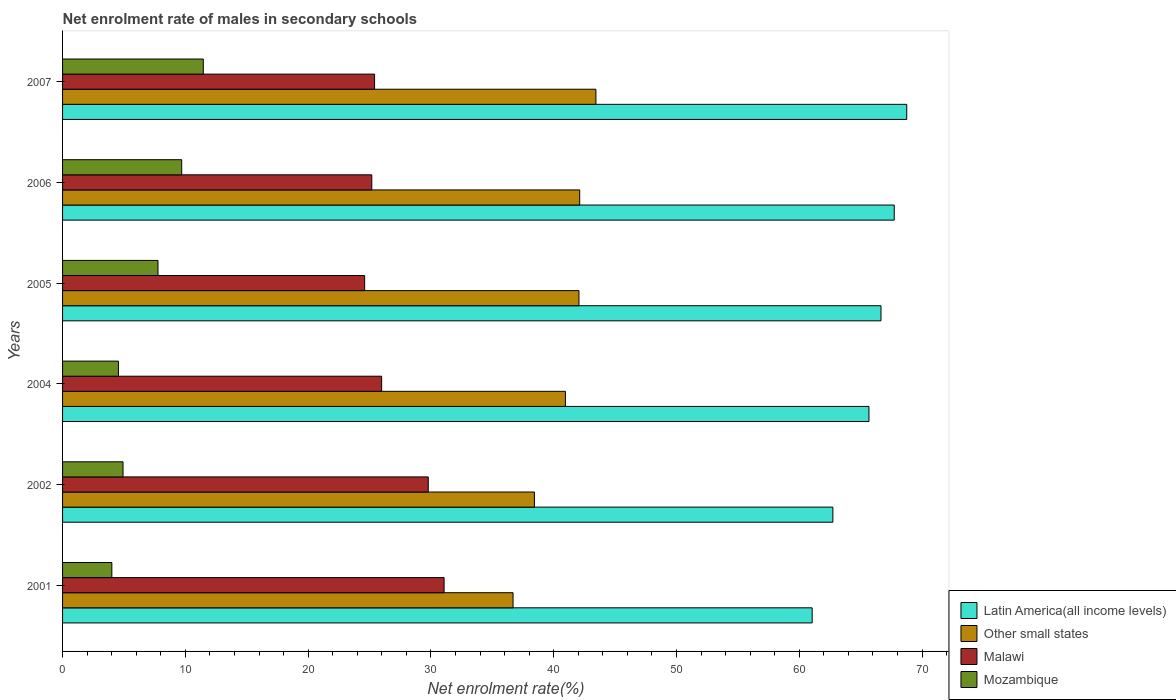How many different coloured bars are there?
Offer a very short reply. 4. Are the number of bars on each tick of the Y-axis equal?
Give a very brief answer. Yes. How many bars are there on the 1st tick from the top?
Keep it short and to the point. 4. How many bars are there on the 2nd tick from the bottom?
Provide a succinct answer. 4. What is the label of the 6th group of bars from the top?
Provide a succinct answer. 2001. What is the net enrolment rate of males in secondary schools in Malawi in 2007?
Your response must be concise. 25.41. Across all years, what is the maximum net enrolment rate of males in secondary schools in Malawi?
Offer a very short reply. 31.07. Across all years, what is the minimum net enrolment rate of males in secondary schools in Latin America(all income levels)?
Ensure brevity in your answer.  61.05. In which year was the net enrolment rate of males in secondary schools in Other small states minimum?
Provide a short and direct response. 2001. What is the total net enrolment rate of males in secondary schools in Latin America(all income levels) in the graph?
Make the answer very short. 392.62. What is the difference between the net enrolment rate of males in secondary schools in Other small states in 2001 and that in 2006?
Offer a terse response. -5.43. What is the difference between the net enrolment rate of males in secondary schools in Mozambique in 2007 and the net enrolment rate of males in secondary schools in Other small states in 2001?
Your answer should be very brief. -25.23. What is the average net enrolment rate of males in secondary schools in Malawi per year?
Offer a terse response. 27.01. In the year 2002, what is the difference between the net enrolment rate of males in secondary schools in Mozambique and net enrolment rate of males in secondary schools in Malawi?
Your answer should be compact. -24.86. In how many years, is the net enrolment rate of males in secondary schools in Malawi greater than 58 %?
Offer a very short reply. 0. What is the ratio of the net enrolment rate of males in secondary schools in Other small states in 2002 to that in 2005?
Your response must be concise. 0.91. Is the net enrolment rate of males in secondary schools in Latin America(all income levels) in 2002 less than that in 2007?
Your answer should be compact. Yes. What is the difference between the highest and the second highest net enrolment rate of males in secondary schools in Malawi?
Your response must be concise. 1.29. What is the difference between the highest and the lowest net enrolment rate of males in secondary schools in Malawi?
Your answer should be compact. 6.47. In how many years, is the net enrolment rate of males in secondary schools in Malawi greater than the average net enrolment rate of males in secondary schools in Malawi taken over all years?
Your answer should be very brief. 2. What does the 2nd bar from the top in 2001 represents?
Provide a succinct answer. Malawi. What does the 3rd bar from the bottom in 2004 represents?
Make the answer very short. Malawi. Is it the case that in every year, the sum of the net enrolment rate of males in secondary schools in Other small states and net enrolment rate of males in secondary schools in Malawi is greater than the net enrolment rate of males in secondary schools in Latin America(all income levels)?
Give a very brief answer. No. How many bars are there?
Keep it short and to the point. 24. Are the values on the major ticks of X-axis written in scientific E-notation?
Make the answer very short. No. Where does the legend appear in the graph?
Your response must be concise. Bottom right. What is the title of the graph?
Keep it short and to the point. Net enrolment rate of males in secondary schools. Does "Fragile and conflict affected situations" appear as one of the legend labels in the graph?
Provide a succinct answer. No. What is the label or title of the X-axis?
Your answer should be compact. Net enrolment rate(%). What is the Net enrolment rate(%) in Latin America(all income levels) in 2001?
Your response must be concise. 61.05. What is the Net enrolment rate(%) in Other small states in 2001?
Your response must be concise. 36.69. What is the Net enrolment rate(%) of Malawi in 2001?
Offer a terse response. 31.07. What is the Net enrolment rate(%) of Mozambique in 2001?
Make the answer very short. 4.01. What is the Net enrolment rate(%) in Latin America(all income levels) in 2002?
Ensure brevity in your answer.  62.74. What is the Net enrolment rate(%) of Other small states in 2002?
Keep it short and to the point. 38.43. What is the Net enrolment rate(%) in Malawi in 2002?
Offer a very short reply. 29.79. What is the Net enrolment rate(%) in Mozambique in 2002?
Offer a very short reply. 4.92. What is the Net enrolment rate(%) in Latin America(all income levels) in 2004?
Your answer should be very brief. 65.68. What is the Net enrolment rate(%) in Other small states in 2004?
Make the answer very short. 40.96. What is the Net enrolment rate(%) of Malawi in 2004?
Offer a terse response. 25.99. What is the Net enrolment rate(%) of Mozambique in 2004?
Offer a terse response. 4.55. What is the Net enrolment rate(%) in Latin America(all income levels) in 2005?
Your response must be concise. 66.66. What is the Net enrolment rate(%) of Other small states in 2005?
Your answer should be compact. 42.06. What is the Net enrolment rate(%) of Malawi in 2005?
Ensure brevity in your answer.  24.6. What is the Net enrolment rate(%) of Mozambique in 2005?
Make the answer very short. 7.77. What is the Net enrolment rate(%) in Latin America(all income levels) in 2006?
Provide a succinct answer. 67.74. What is the Net enrolment rate(%) in Other small states in 2006?
Offer a terse response. 42.12. What is the Net enrolment rate(%) in Malawi in 2006?
Your response must be concise. 25.18. What is the Net enrolment rate(%) in Mozambique in 2006?
Your answer should be compact. 9.7. What is the Net enrolment rate(%) of Latin America(all income levels) in 2007?
Your answer should be very brief. 68.75. What is the Net enrolment rate(%) in Other small states in 2007?
Your answer should be compact. 43.44. What is the Net enrolment rate(%) in Malawi in 2007?
Provide a short and direct response. 25.41. What is the Net enrolment rate(%) of Mozambique in 2007?
Offer a terse response. 11.46. Across all years, what is the maximum Net enrolment rate(%) of Latin America(all income levels)?
Provide a succinct answer. 68.75. Across all years, what is the maximum Net enrolment rate(%) of Other small states?
Offer a terse response. 43.44. Across all years, what is the maximum Net enrolment rate(%) of Malawi?
Offer a very short reply. 31.07. Across all years, what is the maximum Net enrolment rate(%) in Mozambique?
Make the answer very short. 11.46. Across all years, what is the minimum Net enrolment rate(%) of Latin America(all income levels)?
Make the answer very short. 61.05. Across all years, what is the minimum Net enrolment rate(%) of Other small states?
Your answer should be very brief. 36.69. Across all years, what is the minimum Net enrolment rate(%) in Malawi?
Provide a short and direct response. 24.6. Across all years, what is the minimum Net enrolment rate(%) in Mozambique?
Keep it short and to the point. 4.01. What is the total Net enrolment rate(%) in Latin America(all income levels) in the graph?
Your answer should be very brief. 392.62. What is the total Net enrolment rate(%) in Other small states in the graph?
Provide a succinct answer. 243.69. What is the total Net enrolment rate(%) of Malawi in the graph?
Ensure brevity in your answer.  162.05. What is the total Net enrolment rate(%) of Mozambique in the graph?
Ensure brevity in your answer.  42.43. What is the difference between the Net enrolment rate(%) in Latin America(all income levels) in 2001 and that in 2002?
Keep it short and to the point. -1.69. What is the difference between the Net enrolment rate(%) in Other small states in 2001 and that in 2002?
Give a very brief answer. -1.74. What is the difference between the Net enrolment rate(%) of Malawi in 2001 and that in 2002?
Offer a terse response. 1.29. What is the difference between the Net enrolment rate(%) in Mozambique in 2001 and that in 2002?
Provide a short and direct response. -0.91. What is the difference between the Net enrolment rate(%) of Latin America(all income levels) in 2001 and that in 2004?
Give a very brief answer. -4.63. What is the difference between the Net enrolment rate(%) in Other small states in 2001 and that in 2004?
Offer a terse response. -4.26. What is the difference between the Net enrolment rate(%) in Malawi in 2001 and that in 2004?
Give a very brief answer. 5.09. What is the difference between the Net enrolment rate(%) in Mozambique in 2001 and that in 2004?
Make the answer very short. -0.54. What is the difference between the Net enrolment rate(%) of Latin America(all income levels) in 2001 and that in 2005?
Provide a short and direct response. -5.61. What is the difference between the Net enrolment rate(%) in Other small states in 2001 and that in 2005?
Give a very brief answer. -5.37. What is the difference between the Net enrolment rate(%) in Malawi in 2001 and that in 2005?
Provide a succinct answer. 6.47. What is the difference between the Net enrolment rate(%) in Mozambique in 2001 and that in 2005?
Provide a short and direct response. -3.76. What is the difference between the Net enrolment rate(%) in Latin America(all income levels) in 2001 and that in 2006?
Your response must be concise. -6.68. What is the difference between the Net enrolment rate(%) of Other small states in 2001 and that in 2006?
Your response must be concise. -5.43. What is the difference between the Net enrolment rate(%) of Malawi in 2001 and that in 2006?
Ensure brevity in your answer.  5.89. What is the difference between the Net enrolment rate(%) in Mozambique in 2001 and that in 2006?
Provide a short and direct response. -5.69. What is the difference between the Net enrolment rate(%) of Latin America(all income levels) in 2001 and that in 2007?
Offer a terse response. -7.7. What is the difference between the Net enrolment rate(%) of Other small states in 2001 and that in 2007?
Provide a succinct answer. -6.75. What is the difference between the Net enrolment rate(%) in Malawi in 2001 and that in 2007?
Ensure brevity in your answer.  5.66. What is the difference between the Net enrolment rate(%) in Mozambique in 2001 and that in 2007?
Offer a very short reply. -7.45. What is the difference between the Net enrolment rate(%) in Latin America(all income levels) in 2002 and that in 2004?
Offer a very short reply. -2.94. What is the difference between the Net enrolment rate(%) of Other small states in 2002 and that in 2004?
Your answer should be very brief. -2.53. What is the difference between the Net enrolment rate(%) of Malawi in 2002 and that in 2004?
Your response must be concise. 3.8. What is the difference between the Net enrolment rate(%) in Mozambique in 2002 and that in 2004?
Your response must be concise. 0.37. What is the difference between the Net enrolment rate(%) of Latin America(all income levels) in 2002 and that in 2005?
Give a very brief answer. -3.92. What is the difference between the Net enrolment rate(%) in Other small states in 2002 and that in 2005?
Give a very brief answer. -3.63. What is the difference between the Net enrolment rate(%) in Malawi in 2002 and that in 2005?
Offer a terse response. 5.18. What is the difference between the Net enrolment rate(%) of Mozambique in 2002 and that in 2005?
Offer a terse response. -2.85. What is the difference between the Net enrolment rate(%) in Latin America(all income levels) in 2002 and that in 2006?
Give a very brief answer. -5. What is the difference between the Net enrolment rate(%) of Other small states in 2002 and that in 2006?
Your response must be concise. -3.69. What is the difference between the Net enrolment rate(%) of Malawi in 2002 and that in 2006?
Provide a succinct answer. 4.6. What is the difference between the Net enrolment rate(%) of Mozambique in 2002 and that in 2006?
Your answer should be compact. -4.78. What is the difference between the Net enrolment rate(%) of Latin America(all income levels) in 2002 and that in 2007?
Give a very brief answer. -6.02. What is the difference between the Net enrolment rate(%) in Other small states in 2002 and that in 2007?
Provide a succinct answer. -5.01. What is the difference between the Net enrolment rate(%) of Malawi in 2002 and that in 2007?
Keep it short and to the point. 4.37. What is the difference between the Net enrolment rate(%) in Mozambique in 2002 and that in 2007?
Ensure brevity in your answer.  -6.54. What is the difference between the Net enrolment rate(%) of Latin America(all income levels) in 2004 and that in 2005?
Your answer should be very brief. -0.98. What is the difference between the Net enrolment rate(%) of Other small states in 2004 and that in 2005?
Offer a very short reply. -1.1. What is the difference between the Net enrolment rate(%) in Malawi in 2004 and that in 2005?
Ensure brevity in your answer.  1.38. What is the difference between the Net enrolment rate(%) in Mozambique in 2004 and that in 2005?
Provide a succinct answer. -3.22. What is the difference between the Net enrolment rate(%) of Latin America(all income levels) in 2004 and that in 2006?
Give a very brief answer. -2.06. What is the difference between the Net enrolment rate(%) of Other small states in 2004 and that in 2006?
Your response must be concise. -1.16. What is the difference between the Net enrolment rate(%) in Malawi in 2004 and that in 2006?
Ensure brevity in your answer.  0.8. What is the difference between the Net enrolment rate(%) of Mozambique in 2004 and that in 2006?
Provide a short and direct response. -5.15. What is the difference between the Net enrolment rate(%) in Latin America(all income levels) in 2004 and that in 2007?
Your answer should be compact. -3.08. What is the difference between the Net enrolment rate(%) of Other small states in 2004 and that in 2007?
Keep it short and to the point. -2.49. What is the difference between the Net enrolment rate(%) of Malawi in 2004 and that in 2007?
Offer a terse response. 0.58. What is the difference between the Net enrolment rate(%) in Mozambique in 2004 and that in 2007?
Your answer should be compact. -6.91. What is the difference between the Net enrolment rate(%) of Latin America(all income levels) in 2005 and that in 2006?
Ensure brevity in your answer.  -1.08. What is the difference between the Net enrolment rate(%) in Other small states in 2005 and that in 2006?
Your answer should be very brief. -0.06. What is the difference between the Net enrolment rate(%) of Malawi in 2005 and that in 2006?
Offer a terse response. -0.58. What is the difference between the Net enrolment rate(%) of Mozambique in 2005 and that in 2006?
Offer a terse response. -1.93. What is the difference between the Net enrolment rate(%) in Latin America(all income levels) in 2005 and that in 2007?
Offer a very short reply. -2.1. What is the difference between the Net enrolment rate(%) of Other small states in 2005 and that in 2007?
Give a very brief answer. -1.38. What is the difference between the Net enrolment rate(%) of Malawi in 2005 and that in 2007?
Give a very brief answer. -0.81. What is the difference between the Net enrolment rate(%) in Mozambique in 2005 and that in 2007?
Make the answer very short. -3.69. What is the difference between the Net enrolment rate(%) in Latin America(all income levels) in 2006 and that in 2007?
Keep it short and to the point. -1.02. What is the difference between the Net enrolment rate(%) of Other small states in 2006 and that in 2007?
Offer a very short reply. -1.32. What is the difference between the Net enrolment rate(%) of Malawi in 2006 and that in 2007?
Your response must be concise. -0.23. What is the difference between the Net enrolment rate(%) in Mozambique in 2006 and that in 2007?
Keep it short and to the point. -1.76. What is the difference between the Net enrolment rate(%) of Latin America(all income levels) in 2001 and the Net enrolment rate(%) of Other small states in 2002?
Keep it short and to the point. 22.62. What is the difference between the Net enrolment rate(%) in Latin America(all income levels) in 2001 and the Net enrolment rate(%) in Malawi in 2002?
Ensure brevity in your answer.  31.27. What is the difference between the Net enrolment rate(%) of Latin America(all income levels) in 2001 and the Net enrolment rate(%) of Mozambique in 2002?
Keep it short and to the point. 56.13. What is the difference between the Net enrolment rate(%) in Other small states in 2001 and the Net enrolment rate(%) in Malawi in 2002?
Offer a very short reply. 6.91. What is the difference between the Net enrolment rate(%) in Other small states in 2001 and the Net enrolment rate(%) in Mozambique in 2002?
Provide a succinct answer. 31.77. What is the difference between the Net enrolment rate(%) of Malawi in 2001 and the Net enrolment rate(%) of Mozambique in 2002?
Provide a succinct answer. 26.15. What is the difference between the Net enrolment rate(%) of Latin America(all income levels) in 2001 and the Net enrolment rate(%) of Other small states in 2004?
Your answer should be very brief. 20.1. What is the difference between the Net enrolment rate(%) in Latin America(all income levels) in 2001 and the Net enrolment rate(%) in Malawi in 2004?
Make the answer very short. 35.06. What is the difference between the Net enrolment rate(%) of Latin America(all income levels) in 2001 and the Net enrolment rate(%) of Mozambique in 2004?
Provide a succinct answer. 56.5. What is the difference between the Net enrolment rate(%) of Other small states in 2001 and the Net enrolment rate(%) of Malawi in 2004?
Ensure brevity in your answer.  10.7. What is the difference between the Net enrolment rate(%) of Other small states in 2001 and the Net enrolment rate(%) of Mozambique in 2004?
Offer a very short reply. 32.14. What is the difference between the Net enrolment rate(%) in Malawi in 2001 and the Net enrolment rate(%) in Mozambique in 2004?
Make the answer very short. 26.52. What is the difference between the Net enrolment rate(%) of Latin America(all income levels) in 2001 and the Net enrolment rate(%) of Other small states in 2005?
Ensure brevity in your answer.  18.99. What is the difference between the Net enrolment rate(%) in Latin America(all income levels) in 2001 and the Net enrolment rate(%) in Malawi in 2005?
Your answer should be compact. 36.45. What is the difference between the Net enrolment rate(%) in Latin America(all income levels) in 2001 and the Net enrolment rate(%) in Mozambique in 2005?
Make the answer very short. 53.28. What is the difference between the Net enrolment rate(%) in Other small states in 2001 and the Net enrolment rate(%) in Malawi in 2005?
Ensure brevity in your answer.  12.09. What is the difference between the Net enrolment rate(%) of Other small states in 2001 and the Net enrolment rate(%) of Mozambique in 2005?
Provide a short and direct response. 28.92. What is the difference between the Net enrolment rate(%) in Malawi in 2001 and the Net enrolment rate(%) in Mozambique in 2005?
Your answer should be compact. 23.3. What is the difference between the Net enrolment rate(%) of Latin America(all income levels) in 2001 and the Net enrolment rate(%) of Other small states in 2006?
Ensure brevity in your answer.  18.93. What is the difference between the Net enrolment rate(%) of Latin America(all income levels) in 2001 and the Net enrolment rate(%) of Malawi in 2006?
Your answer should be compact. 35.87. What is the difference between the Net enrolment rate(%) in Latin America(all income levels) in 2001 and the Net enrolment rate(%) in Mozambique in 2006?
Your response must be concise. 51.35. What is the difference between the Net enrolment rate(%) of Other small states in 2001 and the Net enrolment rate(%) of Malawi in 2006?
Give a very brief answer. 11.51. What is the difference between the Net enrolment rate(%) in Other small states in 2001 and the Net enrolment rate(%) in Mozambique in 2006?
Offer a terse response. 26.99. What is the difference between the Net enrolment rate(%) in Malawi in 2001 and the Net enrolment rate(%) in Mozambique in 2006?
Offer a terse response. 21.37. What is the difference between the Net enrolment rate(%) in Latin America(all income levels) in 2001 and the Net enrolment rate(%) in Other small states in 2007?
Offer a very short reply. 17.61. What is the difference between the Net enrolment rate(%) in Latin America(all income levels) in 2001 and the Net enrolment rate(%) in Malawi in 2007?
Offer a very short reply. 35.64. What is the difference between the Net enrolment rate(%) of Latin America(all income levels) in 2001 and the Net enrolment rate(%) of Mozambique in 2007?
Give a very brief answer. 49.59. What is the difference between the Net enrolment rate(%) of Other small states in 2001 and the Net enrolment rate(%) of Malawi in 2007?
Offer a very short reply. 11.28. What is the difference between the Net enrolment rate(%) of Other small states in 2001 and the Net enrolment rate(%) of Mozambique in 2007?
Make the answer very short. 25.23. What is the difference between the Net enrolment rate(%) in Malawi in 2001 and the Net enrolment rate(%) in Mozambique in 2007?
Offer a terse response. 19.61. What is the difference between the Net enrolment rate(%) in Latin America(all income levels) in 2002 and the Net enrolment rate(%) in Other small states in 2004?
Provide a short and direct response. 21.78. What is the difference between the Net enrolment rate(%) in Latin America(all income levels) in 2002 and the Net enrolment rate(%) in Malawi in 2004?
Your answer should be very brief. 36.75. What is the difference between the Net enrolment rate(%) of Latin America(all income levels) in 2002 and the Net enrolment rate(%) of Mozambique in 2004?
Your answer should be compact. 58.19. What is the difference between the Net enrolment rate(%) of Other small states in 2002 and the Net enrolment rate(%) of Malawi in 2004?
Offer a very short reply. 12.44. What is the difference between the Net enrolment rate(%) of Other small states in 2002 and the Net enrolment rate(%) of Mozambique in 2004?
Your answer should be very brief. 33.88. What is the difference between the Net enrolment rate(%) of Malawi in 2002 and the Net enrolment rate(%) of Mozambique in 2004?
Ensure brevity in your answer.  25.23. What is the difference between the Net enrolment rate(%) of Latin America(all income levels) in 2002 and the Net enrolment rate(%) of Other small states in 2005?
Provide a succinct answer. 20.68. What is the difference between the Net enrolment rate(%) of Latin America(all income levels) in 2002 and the Net enrolment rate(%) of Malawi in 2005?
Your response must be concise. 38.13. What is the difference between the Net enrolment rate(%) of Latin America(all income levels) in 2002 and the Net enrolment rate(%) of Mozambique in 2005?
Offer a terse response. 54.97. What is the difference between the Net enrolment rate(%) in Other small states in 2002 and the Net enrolment rate(%) in Malawi in 2005?
Make the answer very short. 13.82. What is the difference between the Net enrolment rate(%) in Other small states in 2002 and the Net enrolment rate(%) in Mozambique in 2005?
Provide a succinct answer. 30.66. What is the difference between the Net enrolment rate(%) in Malawi in 2002 and the Net enrolment rate(%) in Mozambique in 2005?
Your response must be concise. 22.01. What is the difference between the Net enrolment rate(%) of Latin America(all income levels) in 2002 and the Net enrolment rate(%) of Other small states in 2006?
Provide a short and direct response. 20.62. What is the difference between the Net enrolment rate(%) of Latin America(all income levels) in 2002 and the Net enrolment rate(%) of Malawi in 2006?
Your response must be concise. 37.55. What is the difference between the Net enrolment rate(%) of Latin America(all income levels) in 2002 and the Net enrolment rate(%) of Mozambique in 2006?
Your response must be concise. 53.04. What is the difference between the Net enrolment rate(%) in Other small states in 2002 and the Net enrolment rate(%) in Malawi in 2006?
Your response must be concise. 13.24. What is the difference between the Net enrolment rate(%) in Other small states in 2002 and the Net enrolment rate(%) in Mozambique in 2006?
Give a very brief answer. 28.73. What is the difference between the Net enrolment rate(%) in Malawi in 2002 and the Net enrolment rate(%) in Mozambique in 2006?
Keep it short and to the point. 20.08. What is the difference between the Net enrolment rate(%) in Latin America(all income levels) in 2002 and the Net enrolment rate(%) in Other small states in 2007?
Offer a very short reply. 19.3. What is the difference between the Net enrolment rate(%) in Latin America(all income levels) in 2002 and the Net enrolment rate(%) in Malawi in 2007?
Ensure brevity in your answer.  37.33. What is the difference between the Net enrolment rate(%) of Latin America(all income levels) in 2002 and the Net enrolment rate(%) of Mozambique in 2007?
Your answer should be very brief. 51.28. What is the difference between the Net enrolment rate(%) of Other small states in 2002 and the Net enrolment rate(%) of Malawi in 2007?
Offer a terse response. 13.02. What is the difference between the Net enrolment rate(%) in Other small states in 2002 and the Net enrolment rate(%) in Mozambique in 2007?
Keep it short and to the point. 26.97. What is the difference between the Net enrolment rate(%) of Malawi in 2002 and the Net enrolment rate(%) of Mozambique in 2007?
Your answer should be very brief. 18.32. What is the difference between the Net enrolment rate(%) in Latin America(all income levels) in 2004 and the Net enrolment rate(%) in Other small states in 2005?
Offer a very short reply. 23.62. What is the difference between the Net enrolment rate(%) of Latin America(all income levels) in 2004 and the Net enrolment rate(%) of Malawi in 2005?
Give a very brief answer. 41.07. What is the difference between the Net enrolment rate(%) of Latin America(all income levels) in 2004 and the Net enrolment rate(%) of Mozambique in 2005?
Your answer should be compact. 57.9. What is the difference between the Net enrolment rate(%) in Other small states in 2004 and the Net enrolment rate(%) in Malawi in 2005?
Ensure brevity in your answer.  16.35. What is the difference between the Net enrolment rate(%) of Other small states in 2004 and the Net enrolment rate(%) of Mozambique in 2005?
Give a very brief answer. 33.18. What is the difference between the Net enrolment rate(%) of Malawi in 2004 and the Net enrolment rate(%) of Mozambique in 2005?
Keep it short and to the point. 18.22. What is the difference between the Net enrolment rate(%) in Latin America(all income levels) in 2004 and the Net enrolment rate(%) in Other small states in 2006?
Provide a succinct answer. 23.56. What is the difference between the Net enrolment rate(%) of Latin America(all income levels) in 2004 and the Net enrolment rate(%) of Malawi in 2006?
Provide a succinct answer. 40.49. What is the difference between the Net enrolment rate(%) of Latin America(all income levels) in 2004 and the Net enrolment rate(%) of Mozambique in 2006?
Your answer should be very brief. 55.97. What is the difference between the Net enrolment rate(%) of Other small states in 2004 and the Net enrolment rate(%) of Malawi in 2006?
Offer a very short reply. 15.77. What is the difference between the Net enrolment rate(%) of Other small states in 2004 and the Net enrolment rate(%) of Mozambique in 2006?
Ensure brevity in your answer.  31.25. What is the difference between the Net enrolment rate(%) of Malawi in 2004 and the Net enrolment rate(%) of Mozambique in 2006?
Provide a succinct answer. 16.29. What is the difference between the Net enrolment rate(%) of Latin America(all income levels) in 2004 and the Net enrolment rate(%) of Other small states in 2007?
Ensure brevity in your answer.  22.24. What is the difference between the Net enrolment rate(%) in Latin America(all income levels) in 2004 and the Net enrolment rate(%) in Malawi in 2007?
Keep it short and to the point. 40.27. What is the difference between the Net enrolment rate(%) of Latin America(all income levels) in 2004 and the Net enrolment rate(%) of Mozambique in 2007?
Offer a terse response. 54.22. What is the difference between the Net enrolment rate(%) of Other small states in 2004 and the Net enrolment rate(%) of Malawi in 2007?
Keep it short and to the point. 15.54. What is the difference between the Net enrolment rate(%) of Other small states in 2004 and the Net enrolment rate(%) of Mozambique in 2007?
Make the answer very short. 29.49. What is the difference between the Net enrolment rate(%) in Malawi in 2004 and the Net enrolment rate(%) in Mozambique in 2007?
Provide a short and direct response. 14.53. What is the difference between the Net enrolment rate(%) in Latin America(all income levels) in 2005 and the Net enrolment rate(%) in Other small states in 2006?
Provide a succinct answer. 24.54. What is the difference between the Net enrolment rate(%) of Latin America(all income levels) in 2005 and the Net enrolment rate(%) of Malawi in 2006?
Ensure brevity in your answer.  41.47. What is the difference between the Net enrolment rate(%) of Latin America(all income levels) in 2005 and the Net enrolment rate(%) of Mozambique in 2006?
Ensure brevity in your answer.  56.95. What is the difference between the Net enrolment rate(%) of Other small states in 2005 and the Net enrolment rate(%) of Malawi in 2006?
Your answer should be compact. 16.87. What is the difference between the Net enrolment rate(%) of Other small states in 2005 and the Net enrolment rate(%) of Mozambique in 2006?
Give a very brief answer. 32.35. What is the difference between the Net enrolment rate(%) of Malawi in 2005 and the Net enrolment rate(%) of Mozambique in 2006?
Your response must be concise. 14.9. What is the difference between the Net enrolment rate(%) in Latin America(all income levels) in 2005 and the Net enrolment rate(%) in Other small states in 2007?
Provide a succinct answer. 23.22. What is the difference between the Net enrolment rate(%) in Latin America(all income levels) in 2005 and the Net enrolment rate(%) in Malawi in 2007?
Your answer should be very brief. 41.25. What is the difference between the Net enrolment rate(%) of Latin America(all income levels) in 2005 and the Net enrolment rate(%) of Mozambique in 2007?
Your response must be concise. 55.2. What is the difference between the Net enrolment rate(%) of Other small states in 2005 and the Net enrolment rate(%) of Malawi in 2007?
Offer a terse response. 16.65. What is the difference between the Net enrolment rate(%) in Other small states in 2005 and the Net enrolment rate(%) in Mozambique in 2007?
Your response must be concise. 30.6. What is the difference between the Net enrolment rate(%) in Malawi in 2005 and the Net enrolment rate(%) in Mozambique in 2007?
Provide a short and direct response. 13.14. What is the difference between the Net enrolment rate(%) in Latin America(all income levels) in 2006 and the Net enrolment rate(%) in Other small states in 2007?
Your response must be concise. 24.3. What is the difference between the Net enrolment rate(%) of Latin America(all income levels) in 2006 and the Net enrolment rate(%) of Malawi in 2007?
Your answer should be very brief. 42.32. What is the difference between the Net enrolment rate(%) of Latin America(all income levels) in 2006 and the Net enrolment rate(%) of Mozambique in 2007?
Your answer should be very brief. 56.28. What is the difference between the Net enrolment rate(%) in Other small states in 2006 and the Net enrolment rate(%) in Malawi in 2007?
Keep it short and to the point. 16.71. What is the difference between the Net enrolment rate(%) in Other small states in 2006 and the Net enrolment rate(%) in Mozambique in 2007?
Your response must be concise. 30.66. What is the difference between the Net enrolment rate(%) in Malawi in 2006 and the Net enrolment rate(%) in Mozambique in 2007?
Provide a short and direct response. 13.72. What is the average Net enrolment rate(%) in Latin America(all income levels) per year?
Give a very brief answer. 65.44. What is the average Net enrolment rate(%) in Other small states per year?
Ensure brevity in your answer.  40.62. What is the average Net enrolment rate(%) in Malawi per year?
Your answer should be very brief. 27.01. What is the average Net enrolment rate(%) in Mozambique per year?
Your response must be concise. 7.07. In the year 2001, what is the difference between the Net enrolment rate(%) in Latin America(all income levels) and Net enrolment rate(%) in Other small states?
Offer a terse response. 24.36. In the year 2001, what is the difference between the Net enrolment rate(%) in Latin America(all income levels) and Net enrolment rate(%) in Malawi?
Give a very brief answer. 29.98. In the year 2001, what is the difference between the Net enrolment rate(%) of Latin America(all income levels) and Net enrolment rate(%) of Mozambique?
Your response must be concise. 57.04. In the year 2001, what is the difference between the Net enrolment rate(%) in Other small states and Net enrolment rate(%) in Malawi?
Offer a terse response. 5.62. In the year 2001, what is the difference between the Net enrolment rate(%) of Other small states and Net enrolment rate(%) of Mozambique?
Offer a very short reply. 32.68. In the year 2001, what is the difference between the Net enrolment rate(%) of Malawi and Net enrolment rate(%) of Mozambique?
Provide a succinct answer. 27.06. In the year 2002, what is the difference between the Net enrolment rate(%) in Latin America(all income levels) and Net enrolment rate(%) in Other small states?
Give a very brief answer. 24.31. In the year 2002, what is the difference between the Net enrolment rate(%) in Latin America(all income levels) and Net enrolment rate(%) in Malawi?
Provide a succinct answer. 32.95. In the year 2002, what is the difference between the Net enrolment rate(%) in Latin America(all income levels) and Net enrolment rate(%) in Mozambique?
Ensure brevity in your answer.  57.81. In the year 2002, what is the difference between the Net enrolment rate(%) in Other small states and Net enrolment rate(%) in Malawi?
Offer a very short reply. 8.64. In the year 2002, what is the difference between the Net enrolment rate(%) of Other small states and Net enrolment rate(%) of Mozambique?
Offer a terse response. 33.5. In the year 2002, what is the difference between the Net enrolment rate(%) in Malawi and Net enrolment rate(%) in Mozambique?
Give a very brief answer. 24.86. In the year 2004, what is the difference between the Net enrolment rate(%) in Latin America(all income levels) and Net enrolment rate(%) in Other small states?
Provide a succinct answer. 24.72. In the year 2004, what is the difference between the Net enrolment rate(%) in Latin America(all income levels) and Net enrolment rate(%) in Malawi?
Offer a very short reply. 39.69. In the year 2004, what is the difference between the Net enrolment rate(%) of Latin America(all income levels) and Net enrolment rate(%) of Mozambique?
Give a very brief answer. 61.13. In the year 2004, what is the difference between the Net enrolment rate(%) of Other small states and Net enrolment rate(%) of Malawi?
Offer a terse response. 14.97. In the year 2004, what is the difference between the Net enrolment rate(%) in Other small states and Net enrolment rate(%) in Mozambique?
Offer a terse response. 36.4. In the year 2004, what is the difference between the Net enrolment rate(%) in Malawi and Net enrolment rate(%) in Mozambique?
Make the answer very short. 21.44. In the year 2005, what is the difference between the Net enrolment rate(%) in Latin America(all income levels) and Net enrolment rate(%) in Other small states?
Provide a short and direct response. 24.6. In the year 2005, what is the difference between the Net enrolment rate(%) of Latin America(all income levels) and Net enrolment rate(%) of Malawi?
Provide a succinct answer. 42.05. In the year 2005, what is the difference between the Net enrolment rate(%) in Latin America(all income levels) and Net enrolment rate(%) in Mozambique?
Provide a short and direct response. 58.88. In the year 2005, what is the difference between the Net enrolment rate(%) in Other small states and Net enrolment rate(%) in Malawi?
Provide a short and direct response. 17.45. In the year 2005, what is the difference between the Net enrolment rate(%) in Other small states and Net enrolment rate(%) in Mozambique?
Offer a terse response. 34.29. In the year 2005, what is the difference between the Net enrolment rate(%) of Malawi and Net enrolment rate(%) of Mozambique?
Make the answer very short. 16.83. In the year 2006, what is the difference between the Net enrolment rate(%) of Latin America(all income levels) and Net enrolment rate(%) of Other small states?
Your answer should be very brief. 25.62. In the year 2006, what is the difference between the Net enrolment rate(%) of Latin America(all income levels) and Net enrolment rate(%) of Malawi?
Offer a very short reply. 42.55. In the year 2006, what is the difference between the Net enrolment rate(%) of Latin America(all income levels) and Net enrolment rate(%) of Mozambique?
Your answer should be very brief. 58.03. In the year 2006, what is the difference between the Net enrolment rate(%) of Other small states and Net enrolment rate(%) of Malawi?
Ensure brevity in your answer.  16.93. In the year 2006, what is the difference between the Net enrolment rate(%) in Other small states and Net enrolment rate(%) in Mozambique?
Provide a short and direct response. 32.42. In the year 2006, what is the difference between the Net enrolment rate(%) in Malawi and Net enrolment rate(%) in Mozambique?
Your answer should be very brief. 15.48. In the year 2007, what is the difference between the Net enrolment rate(%) in Latin America(all income levels) and Net enrolment rate(%) in Other small states?
Keep it short and to the point. 25.31. In the year 2007, what is the difference between the Net enrolment rate(%) of Latin America(all income levels) and Net enrolment rate(%) of Malawi?
Give a very brief answer. 43.34. In the year 2007, what is the difference between the Net enrolment rate(%) of Latin America(all income levels) and Net enrolment rate(%) of Mozambique?
Keep it short and to the point. 57.29. In the year 2007, what is the difference between the Net enrolment rate(%) in Other small states and Net enrolment rate(%) in Malawi?
Give a very brief answer. 18.03. In the year 2007, what is the difference between the Net enrolment rate(%) of Other small states and Net enrolment rate(%) of Mozambique?
Make the answer very short. 31.98. In the year 2007, what is the difference between the Net enrolment rate(%) in Malawi and Net enrolment rate(%) in Mozambique?
Your answer should be compact. 13.95. What is the ratio of the Net enrolment rate(%) of Latin America(all income levels) in 2001 to that in 2002?
Ensure brevity in your answer.  0.97. What is the ratio of the Net enrolment rate(%) of Other small states in 2001 to that in 2002?
Your answer should be compact. 0.95. What is the ratio of the Net enrolment rate(%) of Malawi in 2001 to that in 2002?
Give a very brief answer. 1.04. What is the ratio of the Net enrolment rate(%) of Mozambique in 2001 to that in 2002?
Your response must be concise. 0.81. What is the ratio of the Net enrolment rate(%) in Latin America(all income levels) in 2001 to that in 2004?
Your response must be concise. 0.93. What is the ratio of the Net enrolment rate(%) of Other small states in 2001 to that in 2004?
Your answer should be compact. 0.9. What is the ratio of the Net enrolment rate(%) of Malawi in 2001 to that in 2004?
Your answer should be compact. 1.2. What is the ratio of the Net enrolment rate(%) of Mozambique in 2001 to that in 2004?
Give a very brief answer. 0.88. What is the ratio of the Net enrolment rate(%) of Latin America(all income levels) in 2001 to that in 2005?
Ensure brevity in your answer.  0.92. What is the ratio of the Net enrolment rate(%) in Other small states in 2001 to that in 2005?
Ensure brevity in your answer.  0.87. What is the ratio of the Net enrolment rate(%) of Malawi in 2001 to that in 2005?
Provide a succinct answer. 1.26. What is the ratio of the Net enrolment rate(%) in Mozambique in 2001 to that in 2005?
Offer a very short reply. 0.52. What is the ratio of the Net enrolment rate(%) in Latin America(all income levels) in 2001 to that in 2006?
Ensure brevity in your answer.  0.9. What is the ratio of the Net enrolment rate(%) of Other small states in 2001 to that in 2006?
Offer a terse response. 0.87. What is the ratio of the Net enrolment rate(%) of Malawi in 2001 to that in 2006?
Provide a short and direct response. 1.23. What is the ratio of the Net enrolment rate(%) in Mozambique in 2001 to that in 2006?
Provide a succinct answer. 0.41. What is the ratio of the Net enrolment rate(%) of Latin America(all income levels) in 2001 to that in 2007?
Your answer should be compact. 0.89. What is the ratio of the Net enrolment rate(%) of Other small states in 2001 to that in 2007?
Your response must be concise. 0.84. What is the ratio of the Net enrolment rate(%) in Malawi in 2001 to that in 2007?
Offer a very short reply. 1.22. What is the ratio of the Net enrolment rate(%) in Mozambique in 2001 to that in 2007?
Provide a short and direct response. 0.35. What is the ratio of the Net enrolment rate(%) of Latin America(all income levels) in 2002 to that in 2004?
Keep it short and to the point. 0.96. What is the ratio of the Net enrolment rate(%) in Other small states in 2002 to that in 2004?
Your answer should be very brief. 0.94. What is the ratio of the Net enrolment rate(%) in Malawi in 2002 to that in 2004?
Your answer should be compact. 1.15. What is the ratio of the Net enrolment rate(%) of Mozambique in 2002 to that in 2004?
Keep it short and to the point. 1.08. What is the ratio of the Net enrolment rate(%) in Latin America(all income levels) in 2002 to that in 2005?
Give a very brief answer. 0.94. What is the ratio of the Net enrolment rate(%) of Other small states in 2002 to that in 2005?
Your response must be concise. 0.91. What is the ratio of the Net enrolment rate(%) of Malawi in 2002 to that in 2005?
Your response must be concise. 1.21. What is the ratio of the Net enrolment rate(%) in Mozambique in 2002 to that in 2005?
Keep it short and to the point. 0.63. What is the ratio of the Net enrolment rate(%) of Latin America(all income levels) in 2002 to that in 2006?
Ensure brevity in your answer.  0.93. What is the ratio of the Net enrolment rate(%) in Other small states in 2002 to that in 2006?
Give a very brief answer. 0.91. What is the ratio of the Net enrolment rate(%) of Malawi in 2002 to that in 2006?
Provide a short and direct response. 1.18. What is the ratio of the Net enrolment rate(%) in Mozambique in 2002 to that in 2006?
Ensure brevity in your answer.  0.51. What is the ratio of the Net enrolment rate(%) in Latin America(all income levels) in 2002 to that in 2007?
Ensure brevity in your answer.  0.91. What is the ratio of the Net enrolment rate(%) of Other small states in 2002 to that in 2007?
Ensure brevity in your answer.  0.88. What is the ratio of the Net enrolment rate(%) of Malawi in 2002 to that in 2007?
Give a very brief answer. 1.17. What is the ratio of the Net enrolment rate(%) in Mozambique in 2002 to that in 2007?
Provide a short and direct response. 0.43. What is the ratio of the Net enrolment rate(%) of Latin America(all income levels) in 2004 to that in 2005?
Your answer should be very brief. 0.99. What is the ratio of the Net enrolment rate(%) in Other small states in 2004 to that in 2005?
Your response must be concise. 0.97. What is the ratio of the Net enrolment rate(%) in Malawi in 2004 to that in 2005?
Provide a succinct answer. 1.06. What is the ratio of the Net enrolment rate(%) of Mozambique in 2004 to that in 2005?
Offer a very short reply. 0.59. What is the ratio of the Net enrolment rate(%) of Latin America(all income levels) in 2004 to that in 2006?
Offer a terse response. 0.97. What is the ratio of the Net enrolment rate(%) of Other small states in 2004 to that in 2006?
Provide a succinct answer. 0.97. What is the ratio of the Net enrolment rate(%) of Malawi in 2004 to that in 2006?
Provide a short and direct response. 1.03. What is the ratio of the Net enrolment rate(%) in Mozambique in 2004 to that in 2006?
Your response must be concise. 0.47. What is the ratio of the Net enrolment rate(%) in Latin America(all income levels) in 2004 to that in 2007?
Provide a short and direct response. 0.96. What is the ratio of the Net enrolment rate(%) of Other small states in 2004 to that in 2007?
Keep it short and to the point. 0.94. What is the ratio of the Net enrolment rate(%) in Malawi in 2004 to that in 2007?
Your answer should be very brief. 1.02. What is the ratio of the Net enrolment rate(%) in Mozambique in 2004 to that in 2007?
Ensure brevity in your answer.  0.4. What is the ratio of the Net enrolment rate(%) of Latin America(all income levels) in 2005 to that in 2006?
Your answer should be very brief. 0.98. What is the ratio of the Net enrolment rate(%) in Other small states in 2005 to that in 2006?
Your response must be concise. 1. What is the ratio of the Net enrolment rate(%) in Mozambique in 2005 to that in 2006?
Ensure brevity in your answer.  0.8. What is the ratio of the Net enrolment rate(%) in Latin America(all income levels) in 2005 to that in 2007?
Your answer should be very brief. 0.97. What is the ratio of the Net enrolment rate(%) of Other small states in 2005 to that in 2007?
Your answer should be very brief. 0.97. What is the ratio of the Net enrolment rate(%) in Malawi in 2005 to that in 2007?
Ensure brevity in your answer.  0.97. What is the ratio of the Net enrolment rate(%) of Mozambique in 2005 to that in 2007?
Provide a short and direct response. 0.68. What is the ratio of the Net enrolment rate(%) in Latin America(all income levels) in 2006 to that in 2007?
Offer a very short reply. 0.99. What is the ratio of the Net enrolment rate(%) in Other small states in 2006 to that in 2007?
Offer a very short reply. 0.97. What is the ratio of the Net enrolment rate(%) of Malawi in 2006 to that in 2007?
Provide a short and direct response. 0.99. What is the ratio of the Net enrolment rate(%) in Mozambique in 2006 to that in 2007?
Provide a short and direct response. 0.85. What is the difference between the highest and the second highest Net enrolment rate(%) of Latin America(all income levels)?
Provide a short and direct response. 1.02. What is the difference between the highest and the second highest Net enrolment rate(%) of Other small states?
Offer a terse response. 1.32. What is the difference between the highest and the second highest Net enrolment rate(%) in Malawi?
Give a very brief answer. 1.29. What is the difference between the highest and the second highest Net enrolment rate(%) of Mozambique?
Provide a succinct answer. 1.76. What is the difference between the highest and the lowest Net enrolment rate(%) in Latin America(all income levels)?
Give a very brief answer. 7.7. What is the difference between the highest and the lowest Net enrolment rate(%) of Other small states?
Provide a short and direct response. 6.75. What is the difference between the highest and the lowest Net enrolment rate(%) of Malawi?
Your answer should be very brief. 6.47. What is the difference between the highest and the lowest Net enrolment rate(%) of Mozambique?
Provide a short and direct response. 7.45. 